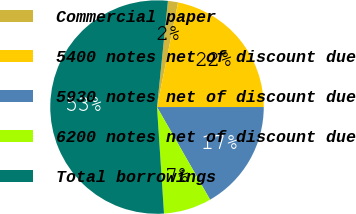<chart> <loc_0><loc_0><loc_500><loc_500><pie_chart><fcel>Commercial paper<fcel>5400 notes net of discount due<fcel>5930 notes net of discount due<fcel>6200 notes net of discount due<fcel>Total borrowings<nl><fcel>1.53%<fcel>21.83%<fcel>16.72%<fcel>7.24%<fcel>52.67%<nl></chart> 